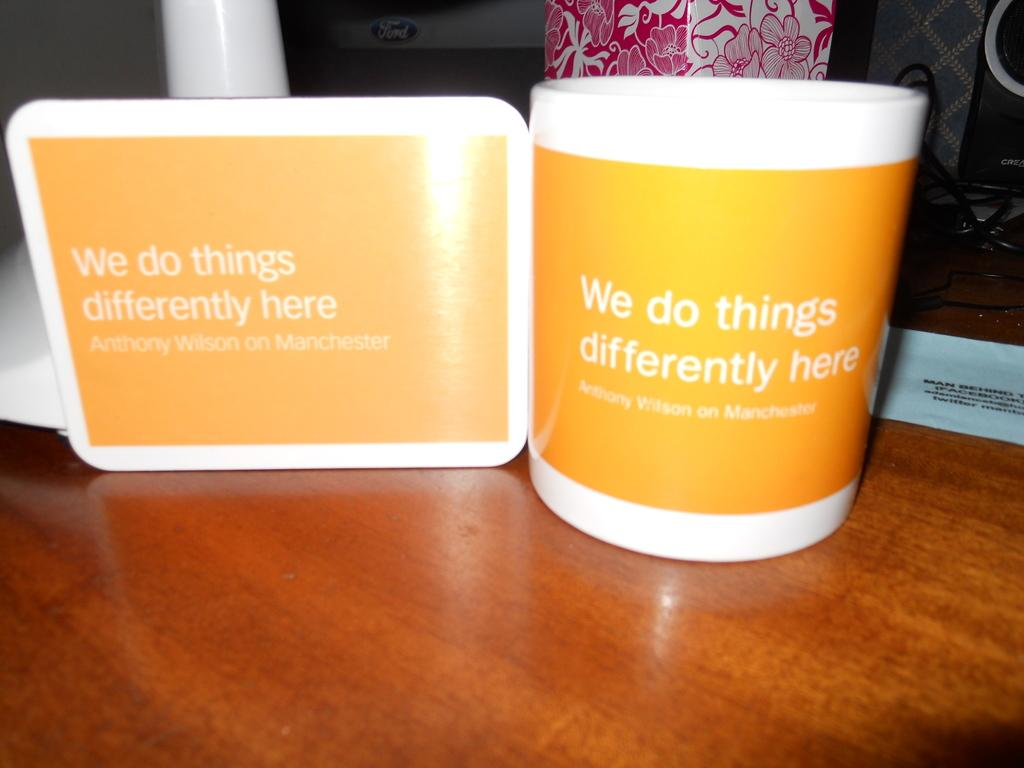Provide a one-sentence caption for the provided image. A white and orange mug that says We do things differently here. 